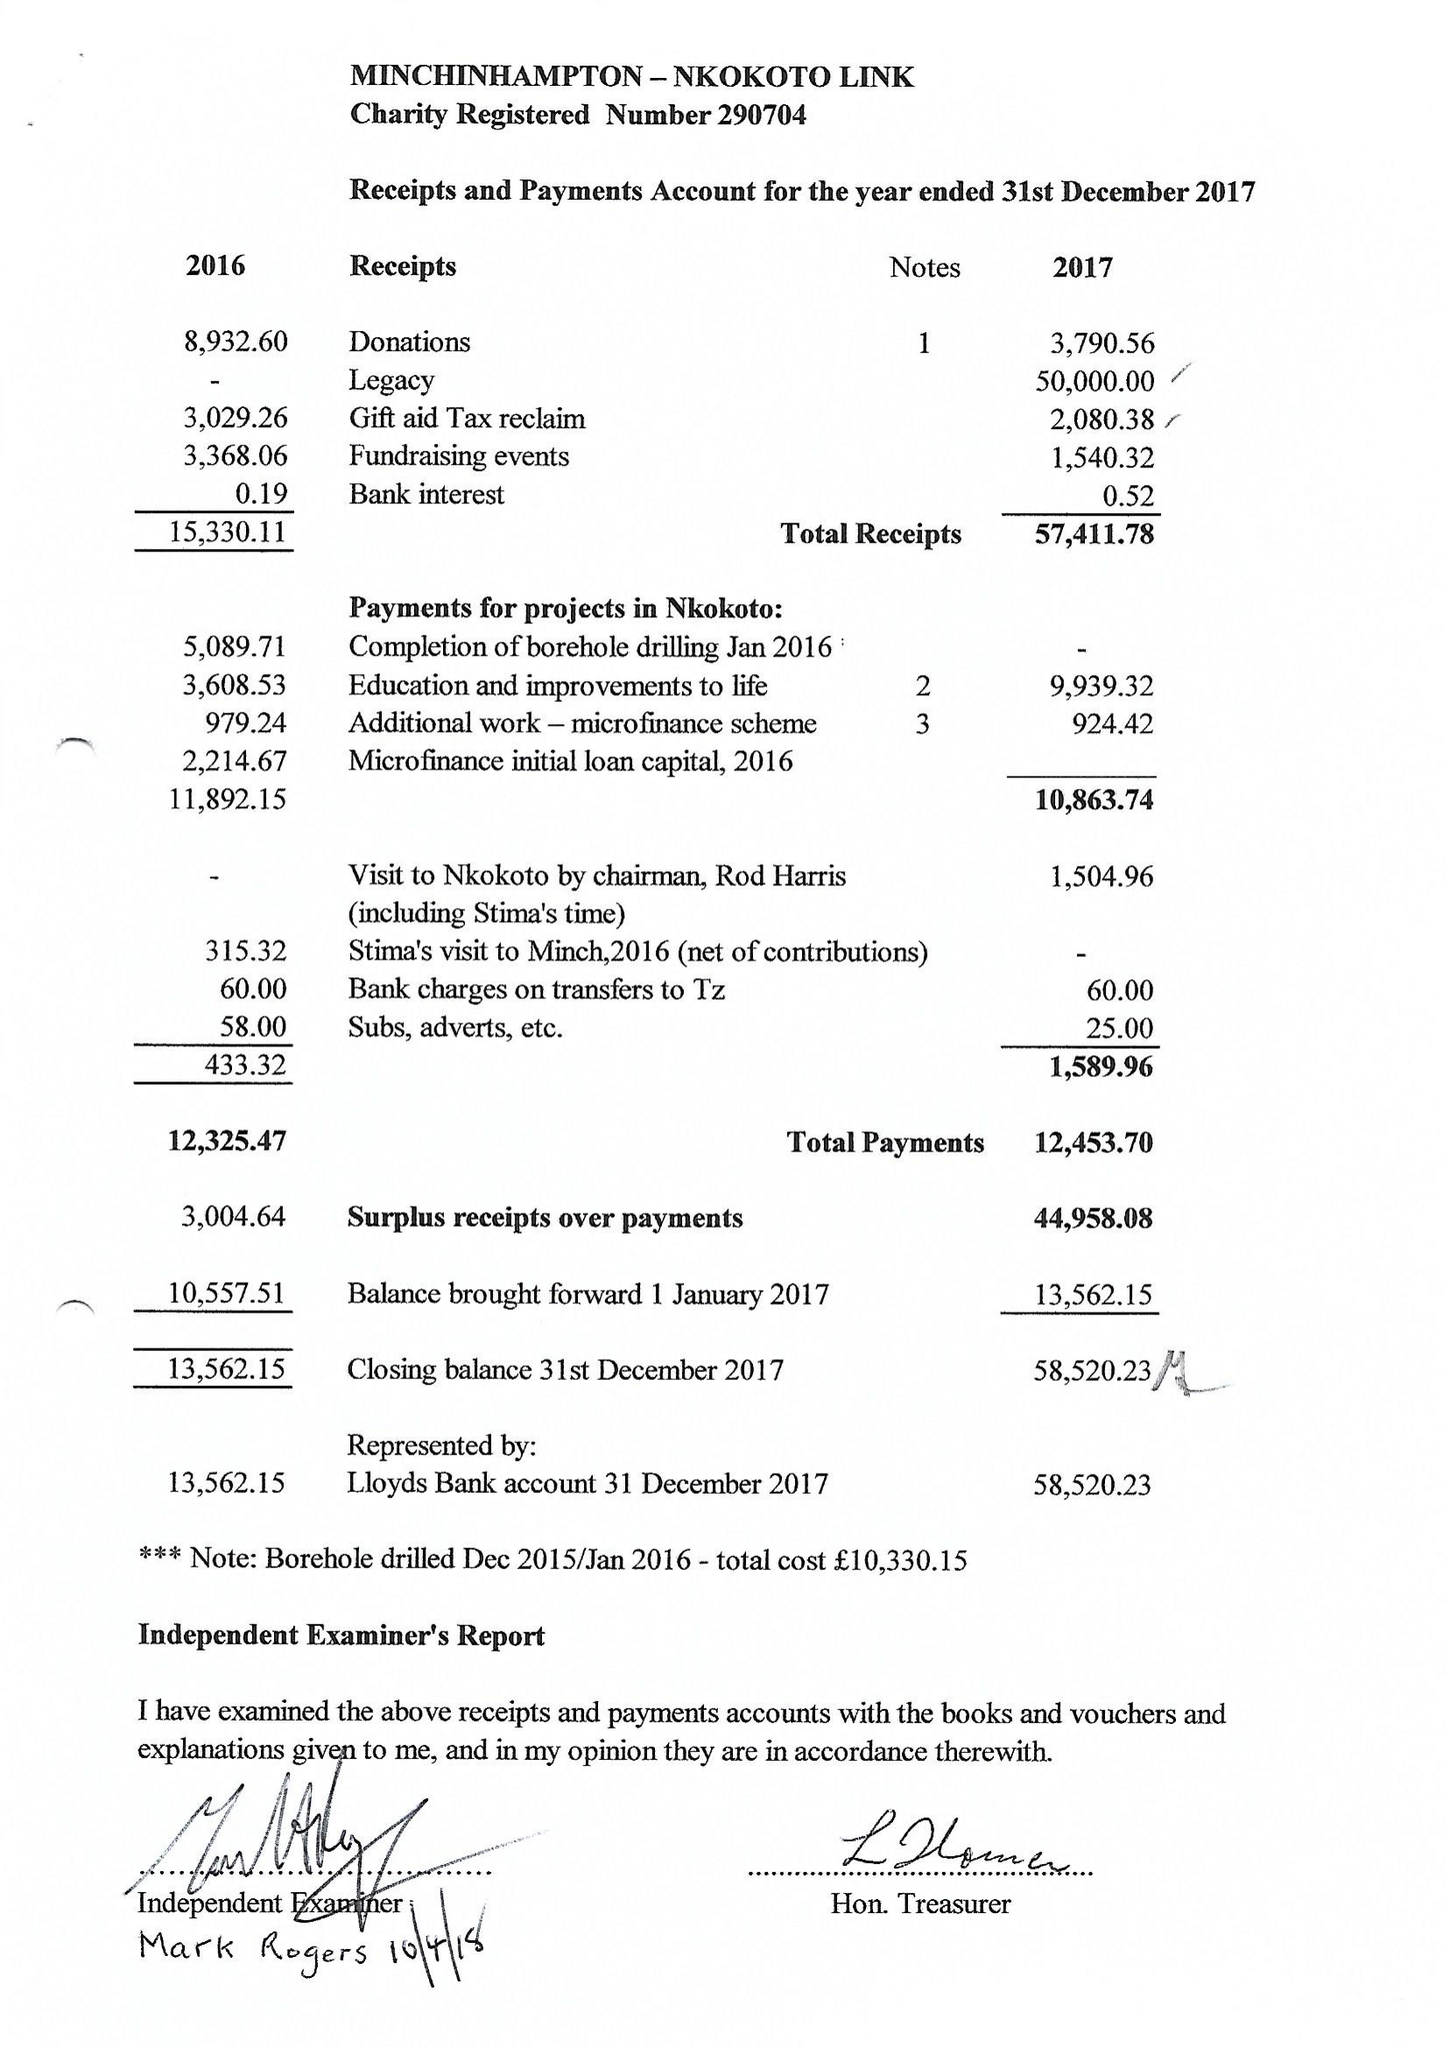What is the value for the address__postcode?
Answer the question using a single word or phrase. GL6 9BZ 